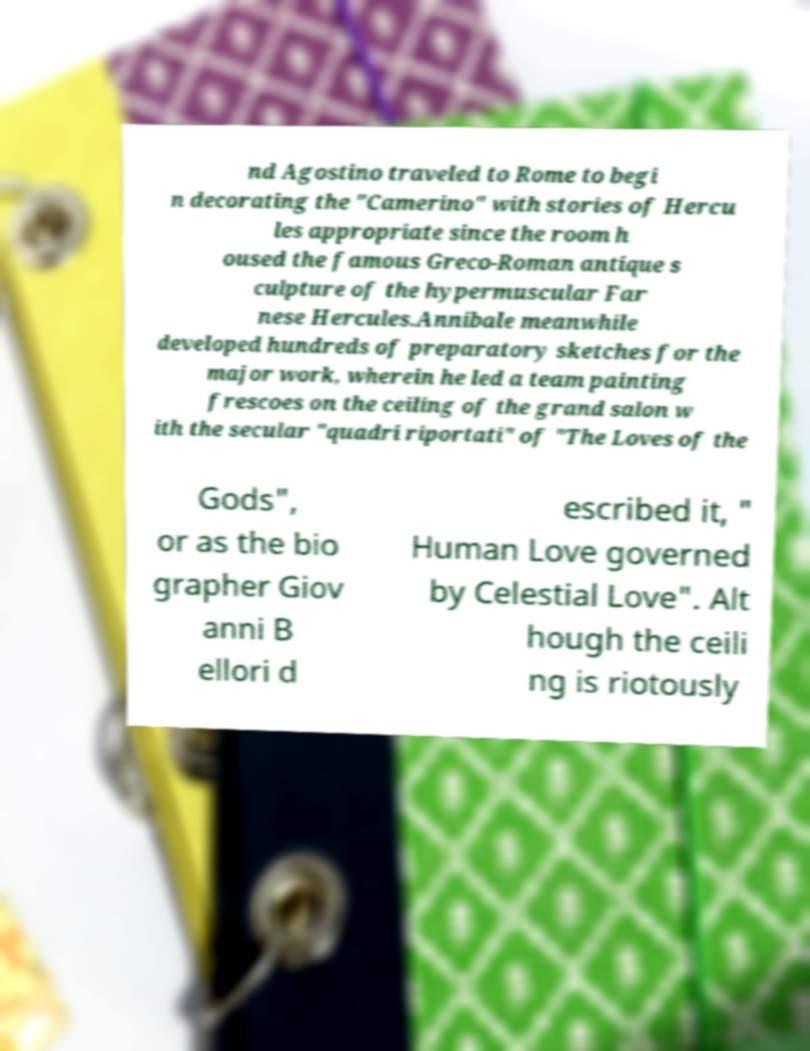Can you accurately transcribe the text from the provided image for me? nd Agostino traveled to Rome to begi n decorating the "Camerino" with stories of Hercu les appropriate since the room h oused the famous Greco-Roman antique s culpture of the hypermuscular Far nese Hercules.Annibale meanwhile developed hundreds of preparatory sketches for the major work, wherein he led a team painting frescoes on the ceiling of the grand salon w ith the secular "quadri riportati" of "The Loves of the Gods", or as the bio grapher Giov anni B ellori d escribed it, " Human Love governed by Celestial Love". Alt hough the ceili ng is riotously 